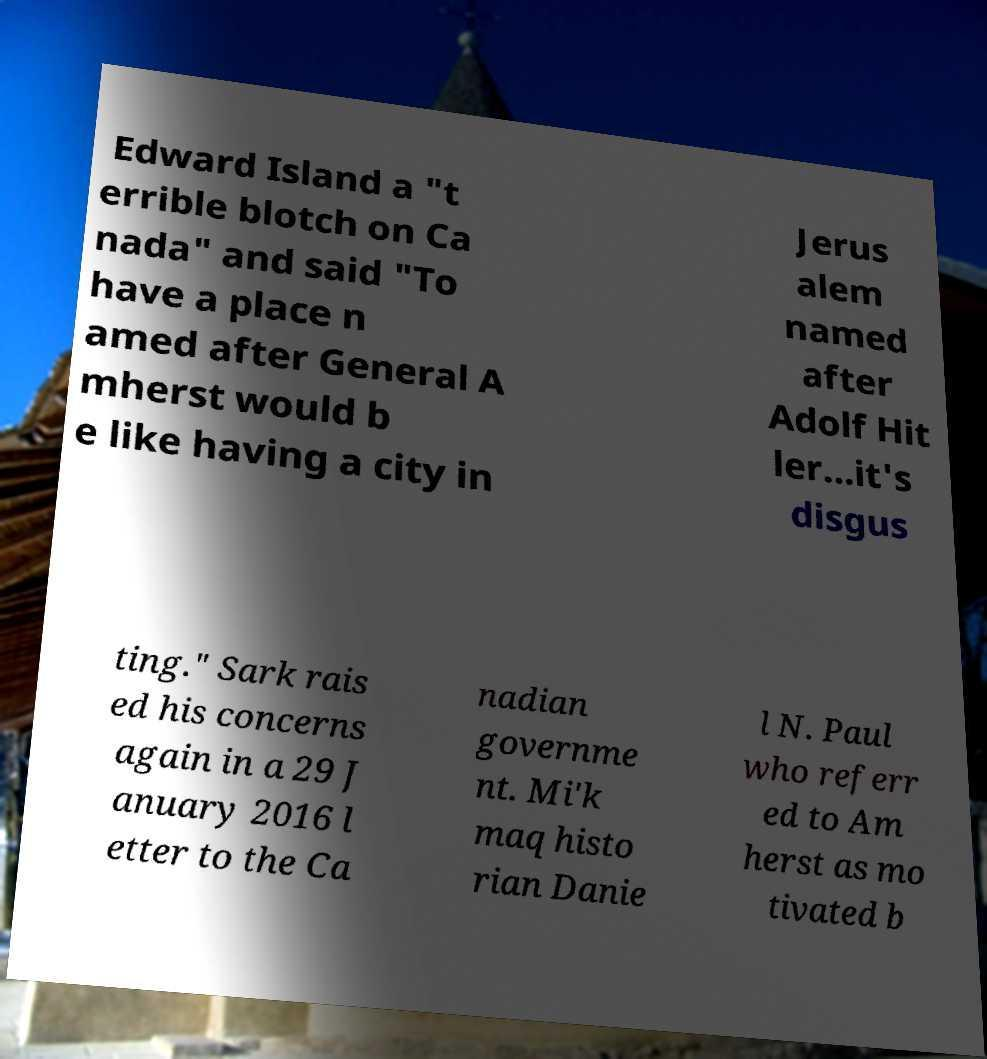I need the written content from this picture converted into text. Can you do that? Edward Island a "t errible blotch on Ca nada" and said "To have a place n amed after General A mherst would b e like having a city in Jerus alem named after Adolf Hit ler...it's disgus ting." Sark rais ed his concerns again in a 29 J anuary 2016 l etter to the Ca nadian governme nt. Mi'k maq histo rian Danie l N. Paul who referr ed to Am herst as mo tivated b 